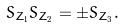<formula> <loc_0><loc_0><loc_500><loc_500>S _ { Z _ { 1 } } S _ { Z _ { 2 } } = \pm S _ { Z _ { 3 } } .</formula> 